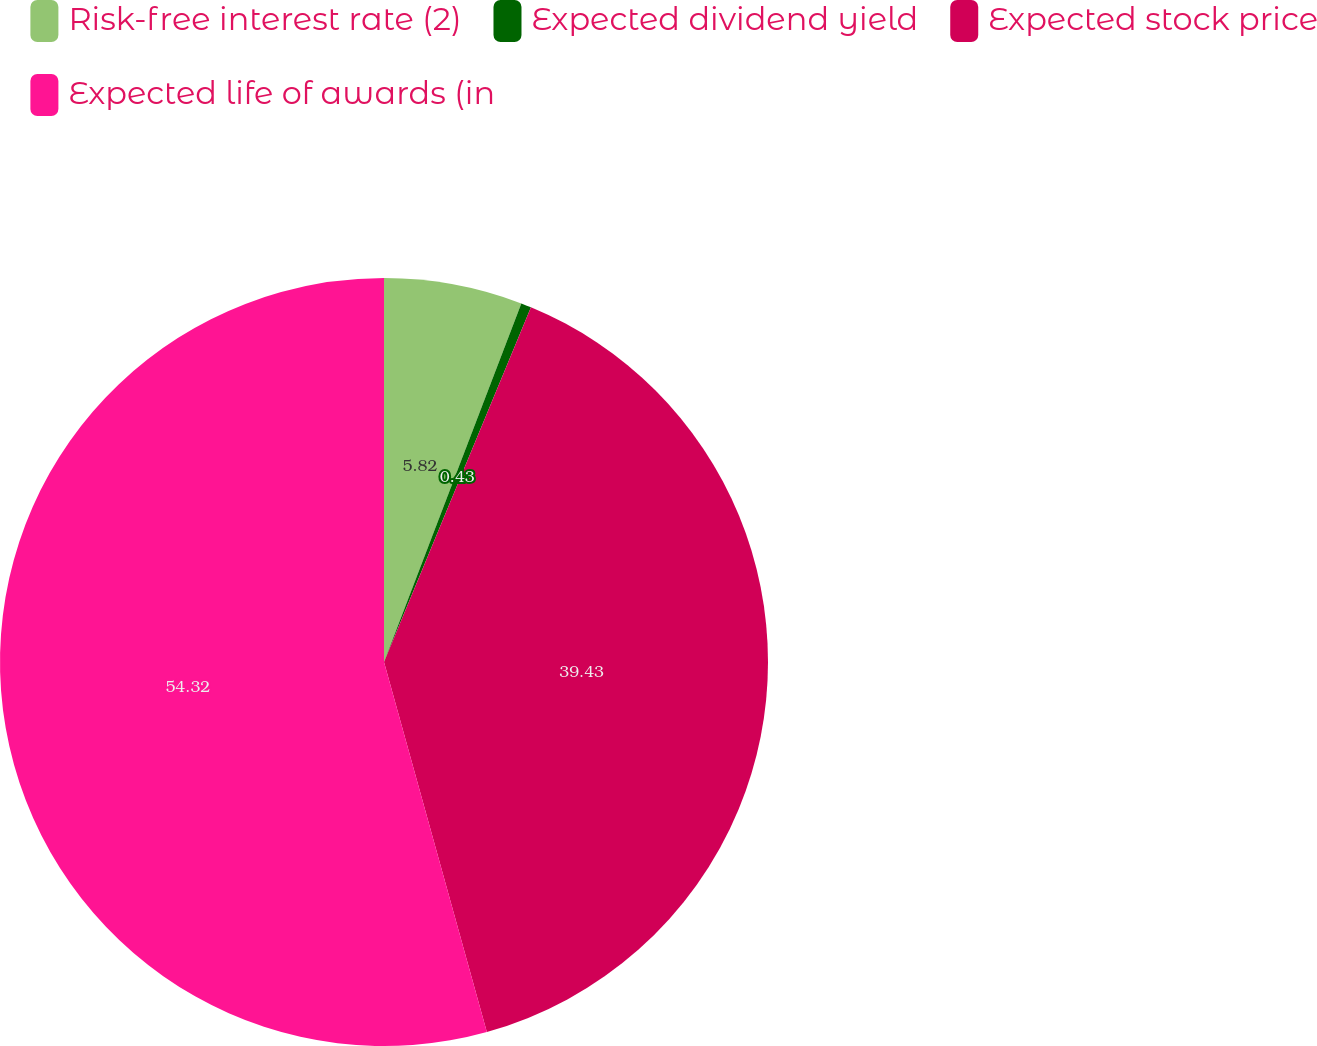Convert chart. <chart><loc_0><loc_0><loc_500><loc_500><pie_chart><fcel>Risk-free interest rate (2)<fcel>Expected dividend yield<fcel>Expected stock price<fcel>Expected life of awards (in<nl><fcel>5.82%<fcel>0.43%<fcel>39.43%<fcel>54.31%<nl></chart> 